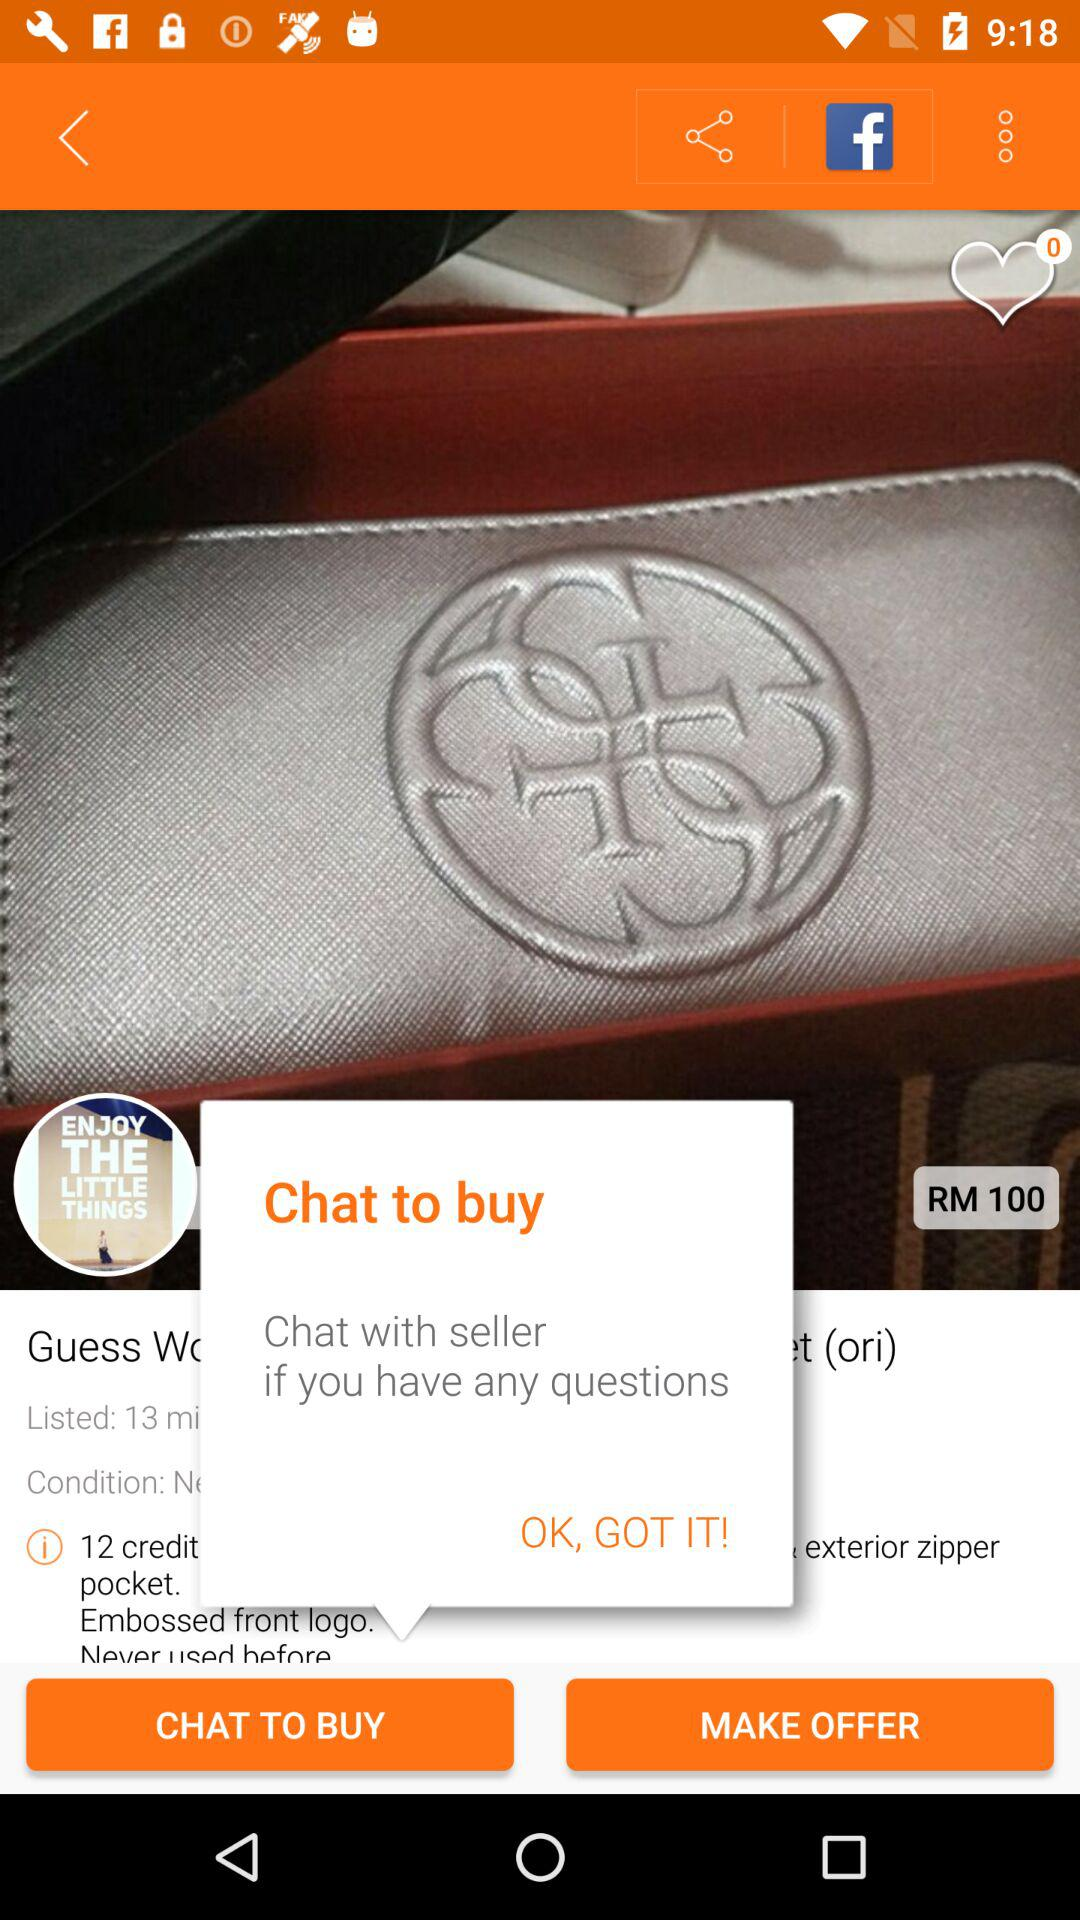What are the possible features of this wallet not visible in the image? Features not visible in the image could include additional compartments for cash or receipts, a clear ID slot, or perhaps a secure coin pocket often found in such wallets. Is this an appropriate gift for someone? Absolutely! A wallet like this, with its elegant design and practicality, would make an excellent gift, especially if it matches the recipient's personal style and needs. 